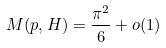<formula> <loc_0><loc_0><loc_500><loc_500>M ( p , H ) = \frac { \pi ^ { 2 } } { 6 } + o ( 1 )</formula> 